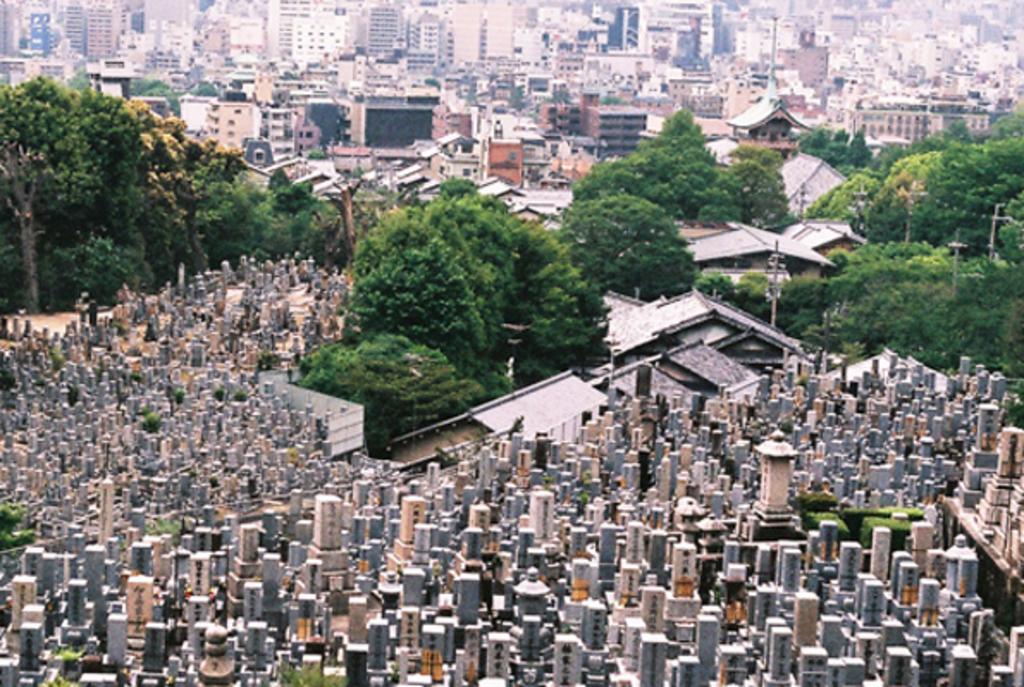How would you summarize this image in a sentence or two? In this image I can see many buildings in multicolor. Background I can see trees in green color. 